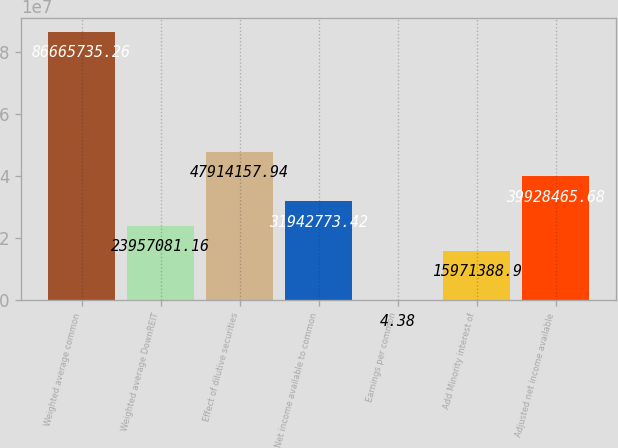<chart> <loc_0><loc_0><loc_500><loc_500><bar_chart><fcel>Weighted average common<fcel>Weighted average DownREIT<fcel>Effect of dilutive securities<fcel>Net income available to common<fcel>Earnings per common<fcel>Add Minority interest of<fcel>Adjusted net income available<nl><fcel>8.66657e+07<fcel>2.39571e+07<fcel>4.79142e+07<fcel>3.19428e+07<fcel>4.38<fcel>1.59714e+07<fcel>3.99285e+07<nl></chart> 